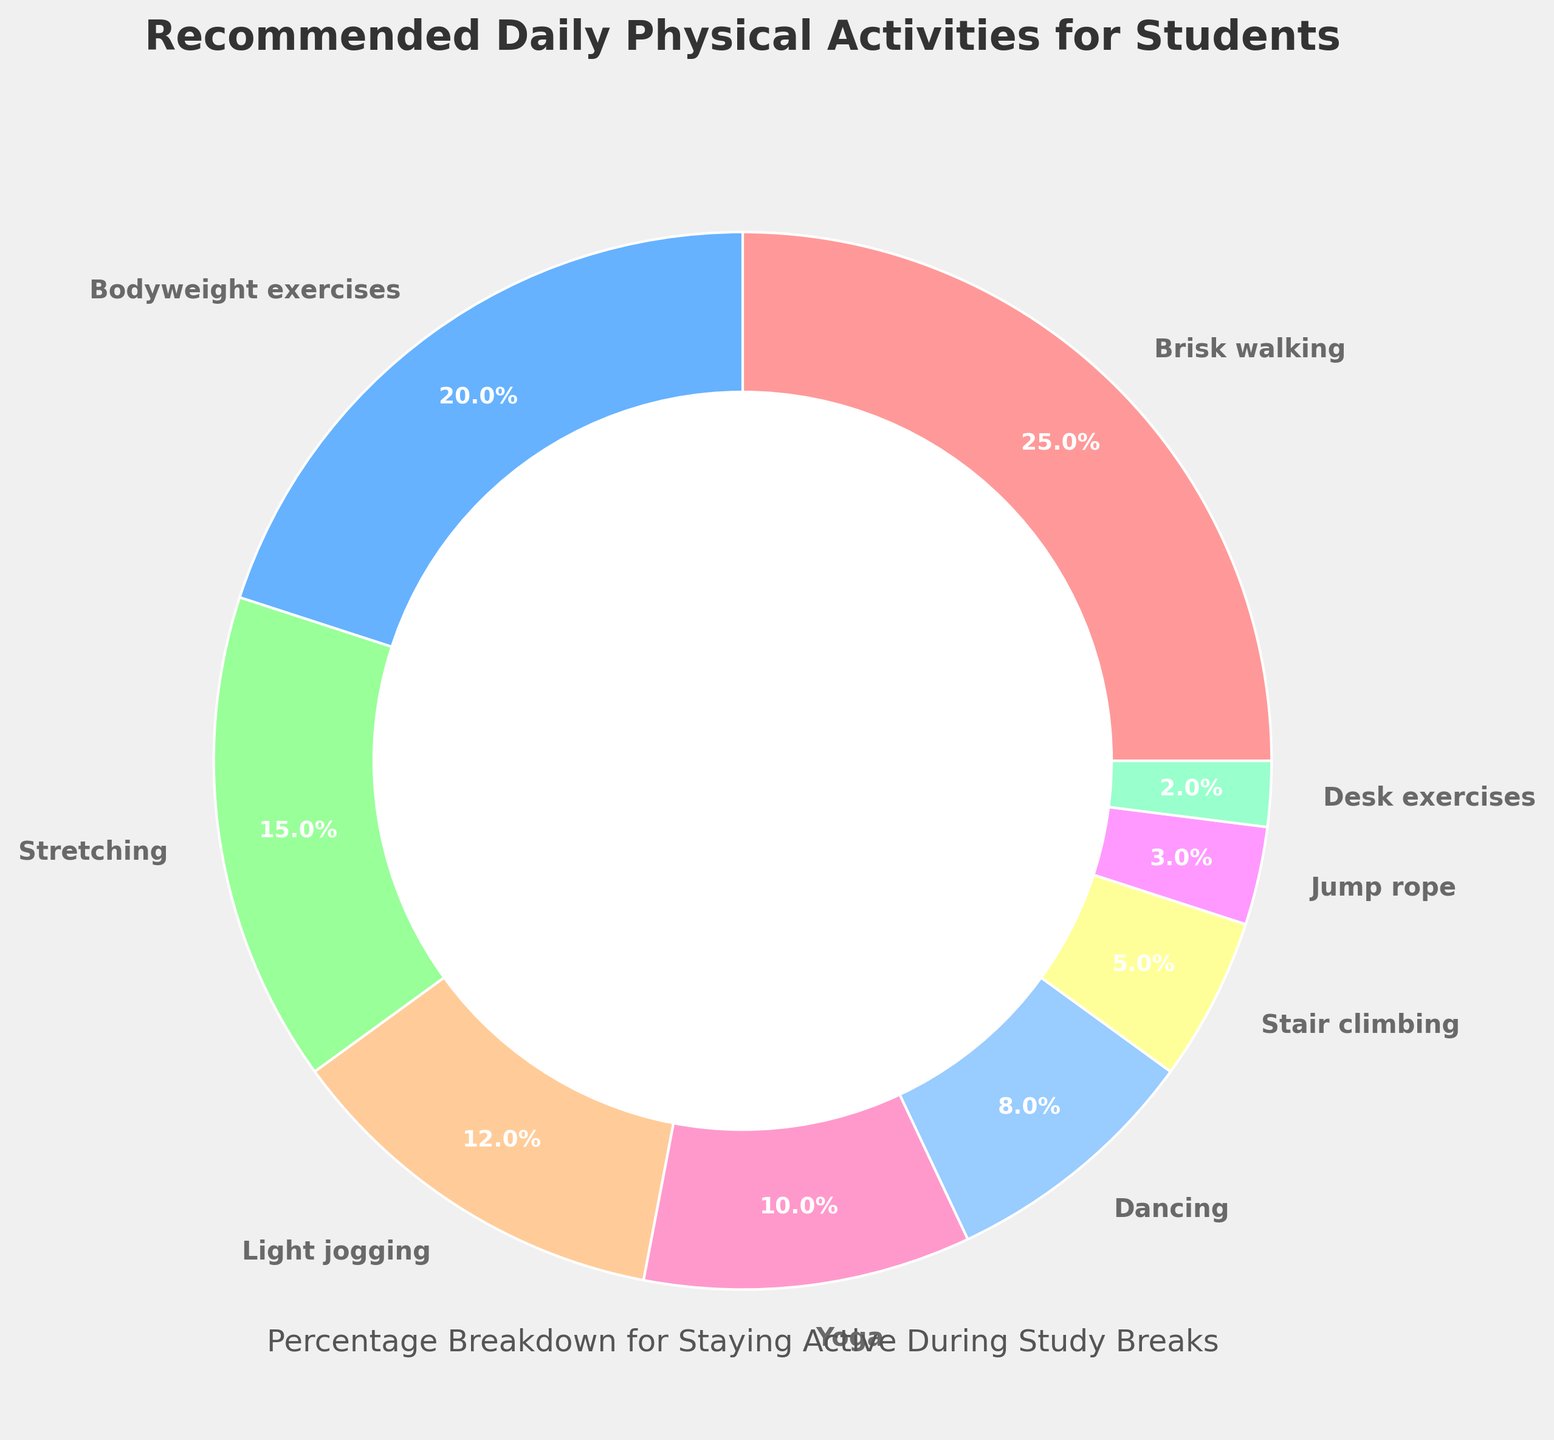Which activity type has the highest percentage? By observing the chart, the activity with the largest wedge is identified.
Answer: Brisk walking Which two activity types have the smallest percentages and what are their combined percentages? Look for the smallest wedges in the pie chart which are Desk exercises and Jump rope, then sum their percentages.
Answer: Desk exercises and Jump rope, 5% What is the total percentage contributed by Bodyweight exercises, Stretching, and Light jogging? Sum the percentages of Bodyweight exercises (20%), Stretching (15%), and Light jogging (12%).
Answer: 47% Is the percentage of Dancing greater or less than the percentage of Stair climbing? Compare the size of the wedges representing Dancing (8%) and Stair climbing (5%).
Answer: Greater Which color represents Yoga and how much percentage does it contribute? Identify the color associated with Yoga (10%) in the legend of the pie chart.
Answer: Light purple, 10% How does the percentage of Stretching compare with the combined percentage of Desk exercises and Jump rope? Compare the percentage of Stretching (15%) with the sum of Desk exercises (2%) and Jump rope (3%).
Answer: Greater What percentage of activities involve exercises that can be done at a desk? Identify Desk exercises from the chart and note its contribution.
Answer: 2% Which activity types together make up more than 50% of the chart? List the activities with the highest percentages until their sum exceeds 50%, i.e., Brisk walking (25%) and Bodyweight exercises (20%) and Stretching (15%).
Answer: Brisk walking, Bodyweight exercises, and Stretching How do the combined percentages of Yoga and Dancing compare with the percentage of Brisk walking? Sum the percentages of Yoga (10%) and Dancing (8%) and compare with Brisk walking (25%).
Answer: Less If another activity were added with a percentage of 10%, what would the new total percentage for all activities be? Sum all the existing percentages (100%) and add the new activity's percentage (10%).
Answer: 110% 